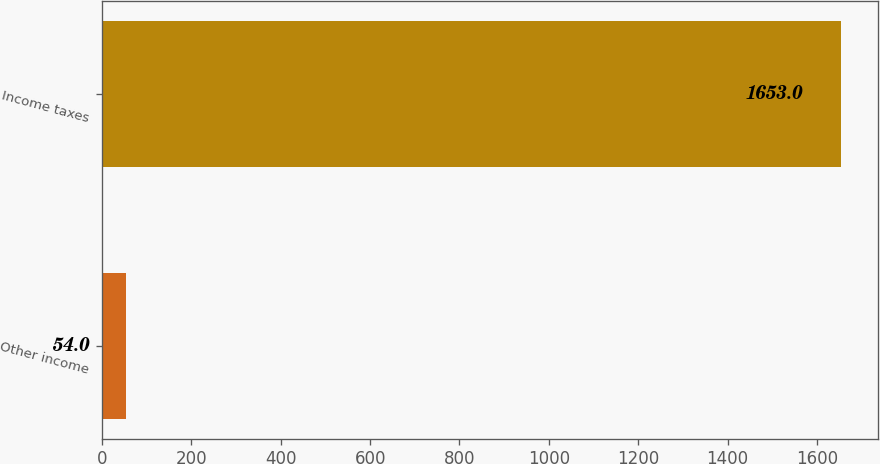Convert chart to OTSL. <chart><loc_0><loc_0><loc_500><loc_500><bar_chart><fcel>Other income<fcel>Income taxes<nl><fcel>54<fcel>1653<nl></chart> 